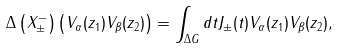Convert formula to latex. <formula><loc_0><loc_0><loc_500><loc_500>\Delta \left ( X ^ { - } _ { \pm } \right ) \left ( V _ { \alpha } ( z _ { 1 } ) V _ { \beta } ( z _ { 2 } ) \right ) = \int _ { \Delta G } d t J _ { \pm } ( t ) V _ { \alpha } ( z _ { 1 } ) V _ { \beta } ( z _ { 2 } ) ,</formula> 